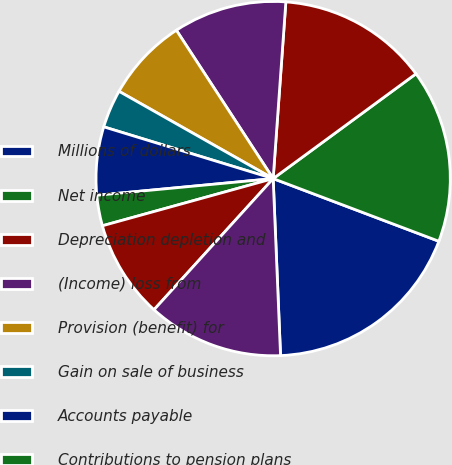Convert chart. <chart><loc_0><loc_0><loc_500><loc_500><pie_chart><fcel>Millions of dollars<fcel>Net income<fcel>Depreciation depletion and<fcel>(Income) loss from<fcel>Provision (benefit) for<fcel>Gain on sale of business<fcel>Accounts payable<fcel>Contributions to pension plans<fcel>Inventories<fcel>Receivables<nl><fcel>18.58%<fcel>15.83%<fcel>13.78%<fcel>10.34%<fcel>7.6%<fcel>3.48%<fcel>6.22%<fcel>2.79%<fcel>8.97%<fcel>12.4%<nl></chart> 